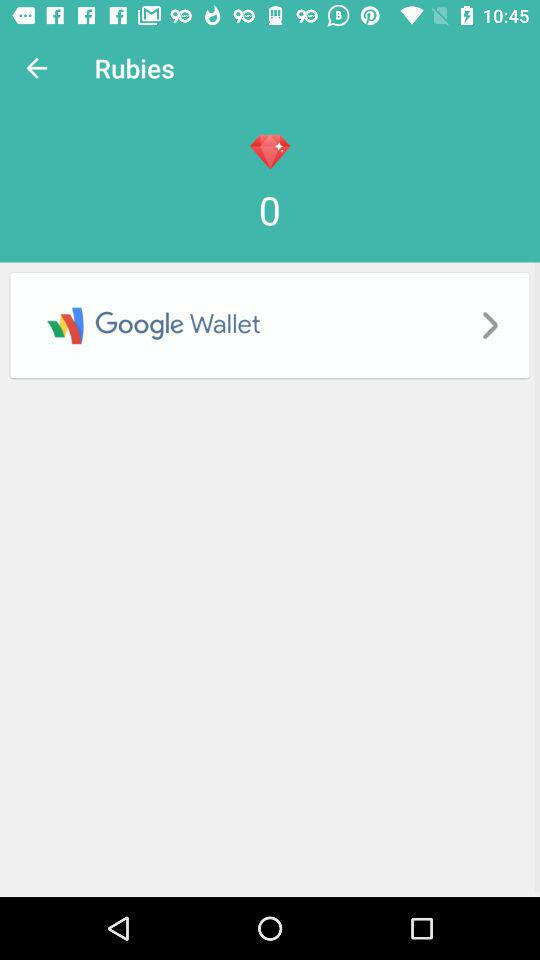What is the name of the wallet? The name of the wallet is "Google Wallet". 